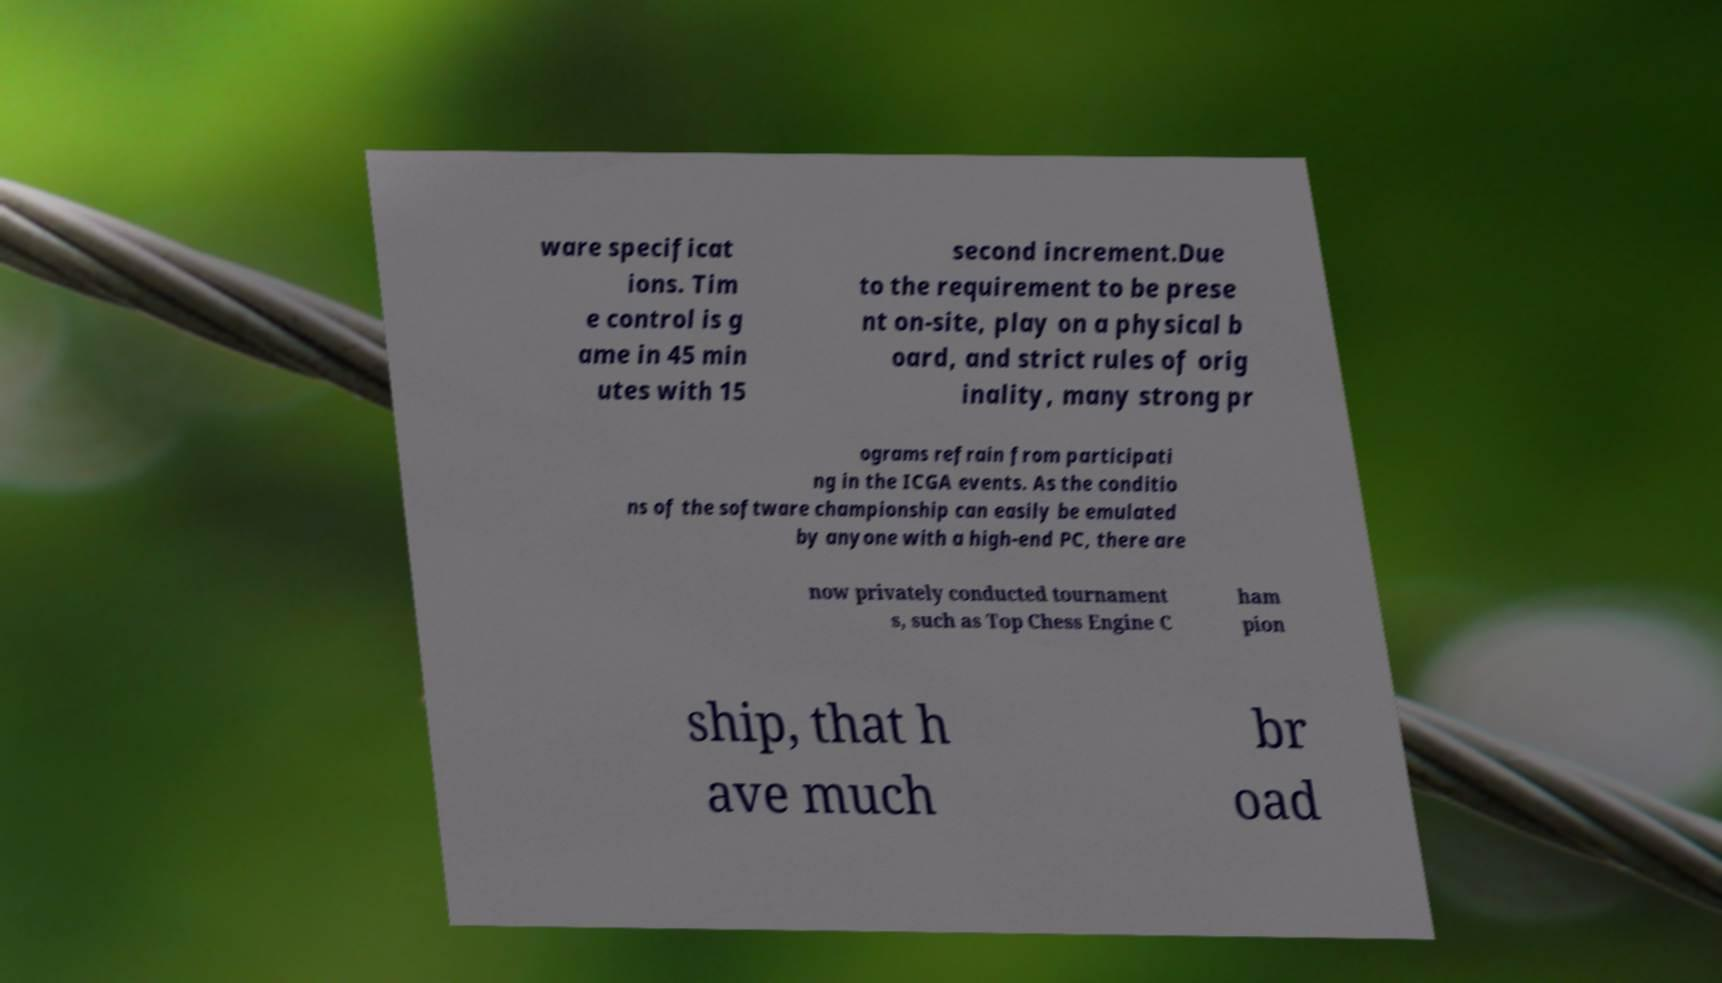Could you assist in decoding the text presented in this image and type it out clearly? ware specificat ions. Tim e control is g ame in 45 min utes with 15 second increment.Due to the requirement to be prese nt on-site, play on a physical b oard, and strict rules of orig inality, many strong pr ograms refrain from participati ng in the ICGA events. As the conditio ns of the software championship can easily be emulated by anyone with a high-end PC, there are now privately conducted tournament s, such as Top Chess Engine C ham pion ship, that h ave much br oad 